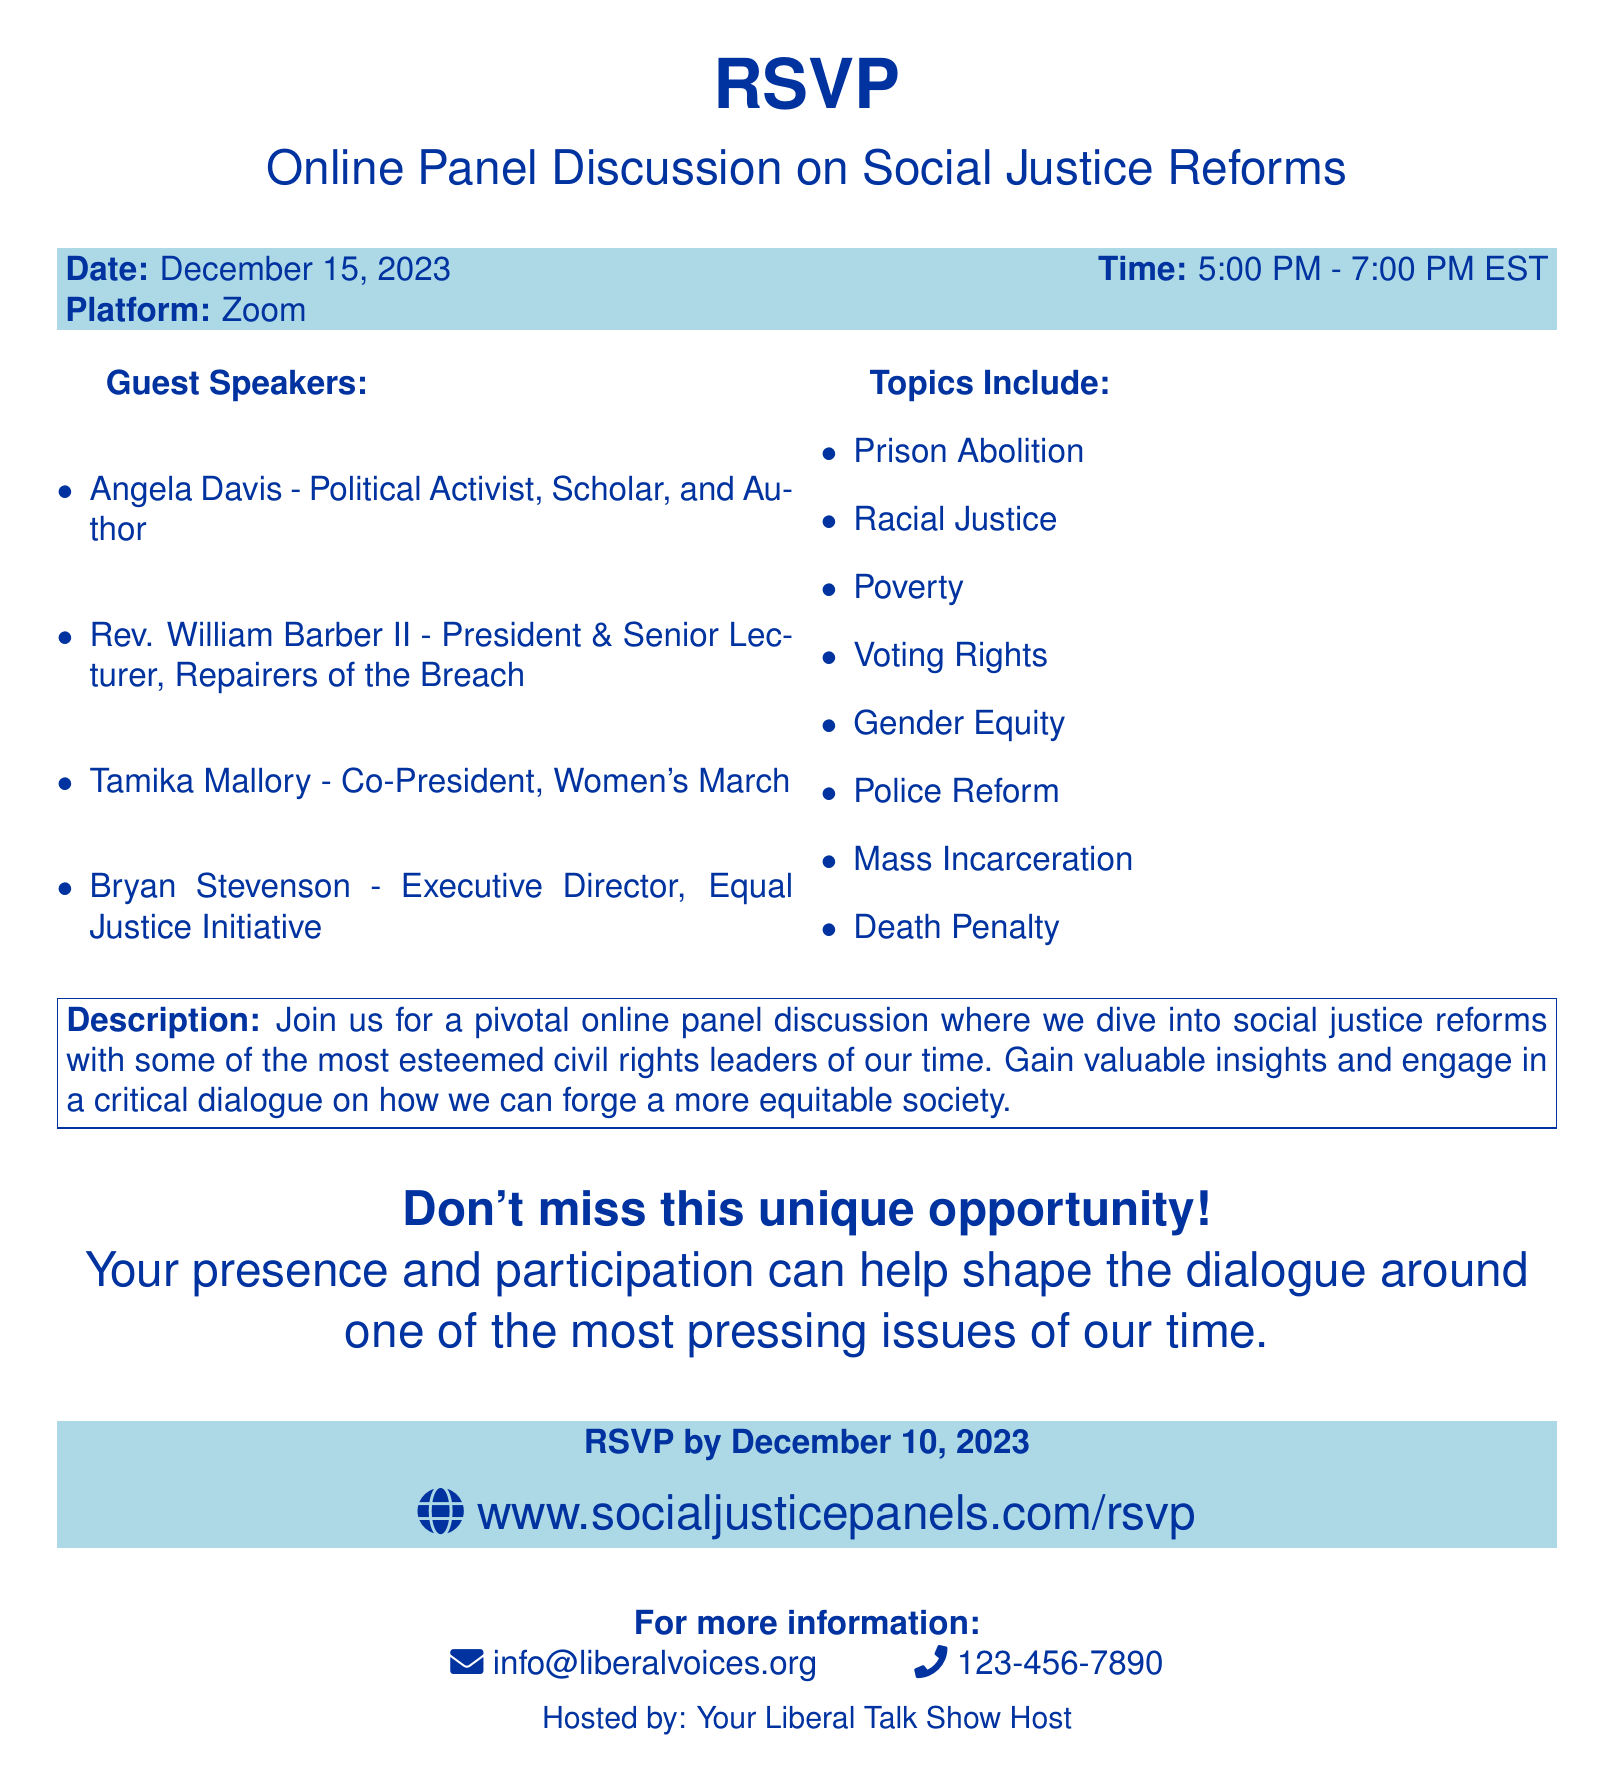What is the date of the event? The date of the event is specified in the document under the RSVP section.
Answer: December 15, 2023 What time does the panel discussion start? The starting time of the panel discussion is listed in the RSVP section of the document.
Answer: 5:00 PM Who is one of the guest speakers? Several guest speakers are listed in the document, making it possible to mention any of them.
Answer: Angela Davis What topic related to social justice is mentioned? A list of topics is provided in the document, any of which can be considered an answer.
Answer: Police Reform What is the RSVPing deadline? The deadline for RSVPing is clearly indicated in the document.
Answer: December 10, 2023 How can participants RSVP for the event? The RSVP method is mentioned in the document, giving a specific URL to follow.
Answer: www.socialjusticepanels.com/rsvp What is the email for more information? The document includes contact information, including an email address for inquiries.
Answer: info@liberalvoices.org What is the platform used for the discussion? The platform for hosting the online panel discussion is specified in the document.
Answer: Zoom 